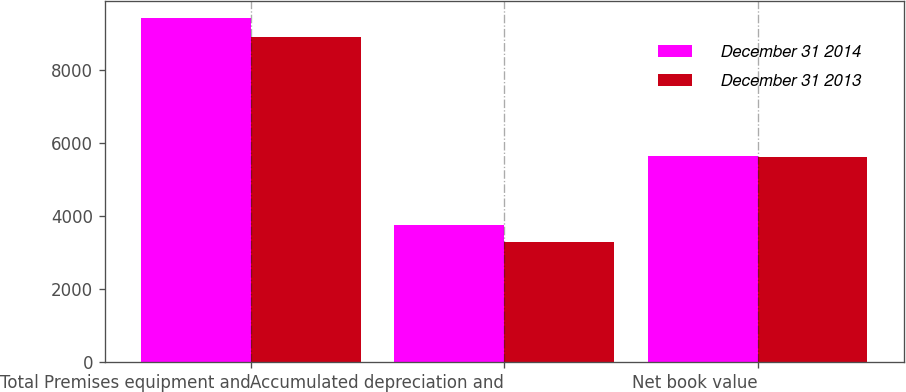<chart> <loc_0><loc_0><loc_500><loc_500><stacked_bar_chart><ecel><fcel>Total Premises equipment and<fcel>Accumulated depreciation and<fcel>Net book value<nl><fcel>December 31 2014<fcel>9416<fcel>3773<fcel>5643<nl><fcel>December 31 2013<fcel>8903<fcel>3285<fcel>5618<nl></chart> 